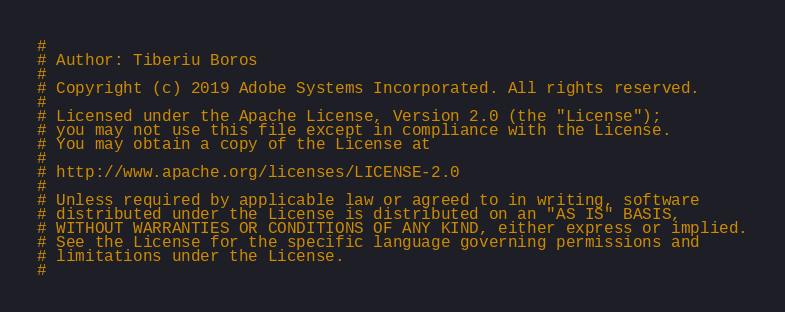<code> <loc_0><loc_0><loc_500><loc_500><_Python_>#
# Author: Tiberiu Boros
#
# Copyright (c) 2019 Adobe Systems Incorporated. All rights reserved.
#
# Licensed under the Apache License, Version 2.0 (the "License");
# you may not use this file except in compliance with the License.
# You may obtain a copy of the License at
#
# http://www.apache.org/licenses/LICENSE-2.0
#
# Unless required by applicable law or agreed to in writing, software
# distributed under the License is distributed on an "AS IS" BASIS,
# WITHOUT WARRANTIES OR CONDITIONS OF ANY KIND, either express or implied.
# See the License for the specific language governing permissions and
# limitations under the License.
#
</code> 